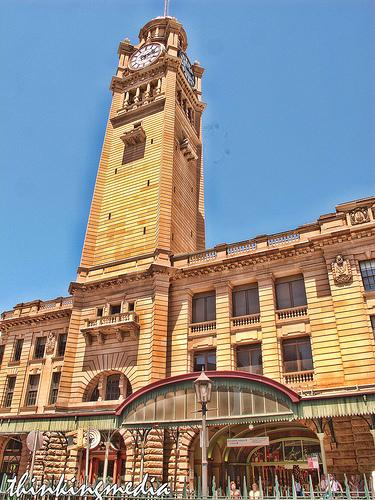Describe any human presence or activities visible in the image. People can be seen standing outside near the clock tower, possibly interacting or waiting, with a person wearing a white shirt among them. Illustrate the main architectural features of the building in the image. The building features a large clock tower, archways, small column details, a balcony design, and various styles of windows on its facade. List some of the smaller details and items found in the image. The image includes a light pole, a hanging sign, a small window slit, a green patina iron fence, and a tall street light on the sidewalk. Comment on the architectural style of the building in the image. The building presents a mix of classic architecture with archways, decorative designs, and an impressive clock tower as its centerpiece. Form a specific description of the clock tower and its surroundings. The brown and yellow clock tower with two clocks stands tall in front of the building with small columns, window slits, and a roof over it while people stand outside. Provide a brief description of the primary scene depicted in the image. A large clock tower with archways and decorative architecture stands tall against a clear, blue sky, while people gather around and a light pole stands nearby. How would you describe the color palette of the image and its effect on the mood? The image uses a warm color palette with brown, yellow, and red tones, which create a welcoming atmosphere complemented by the clear blue sky. What objects and colors can you identify in the landscape? The landscape features a brown and yellow clock tower, a red archway, blue sky without clouds, green patina iron fence, and a red and white sign. Explain the atmosphere of the image in terms of weather and clarity of the sky. The image showcases a clear day with bright blue sky without any clouds, providing a pleasant and sunny atmosphere. 